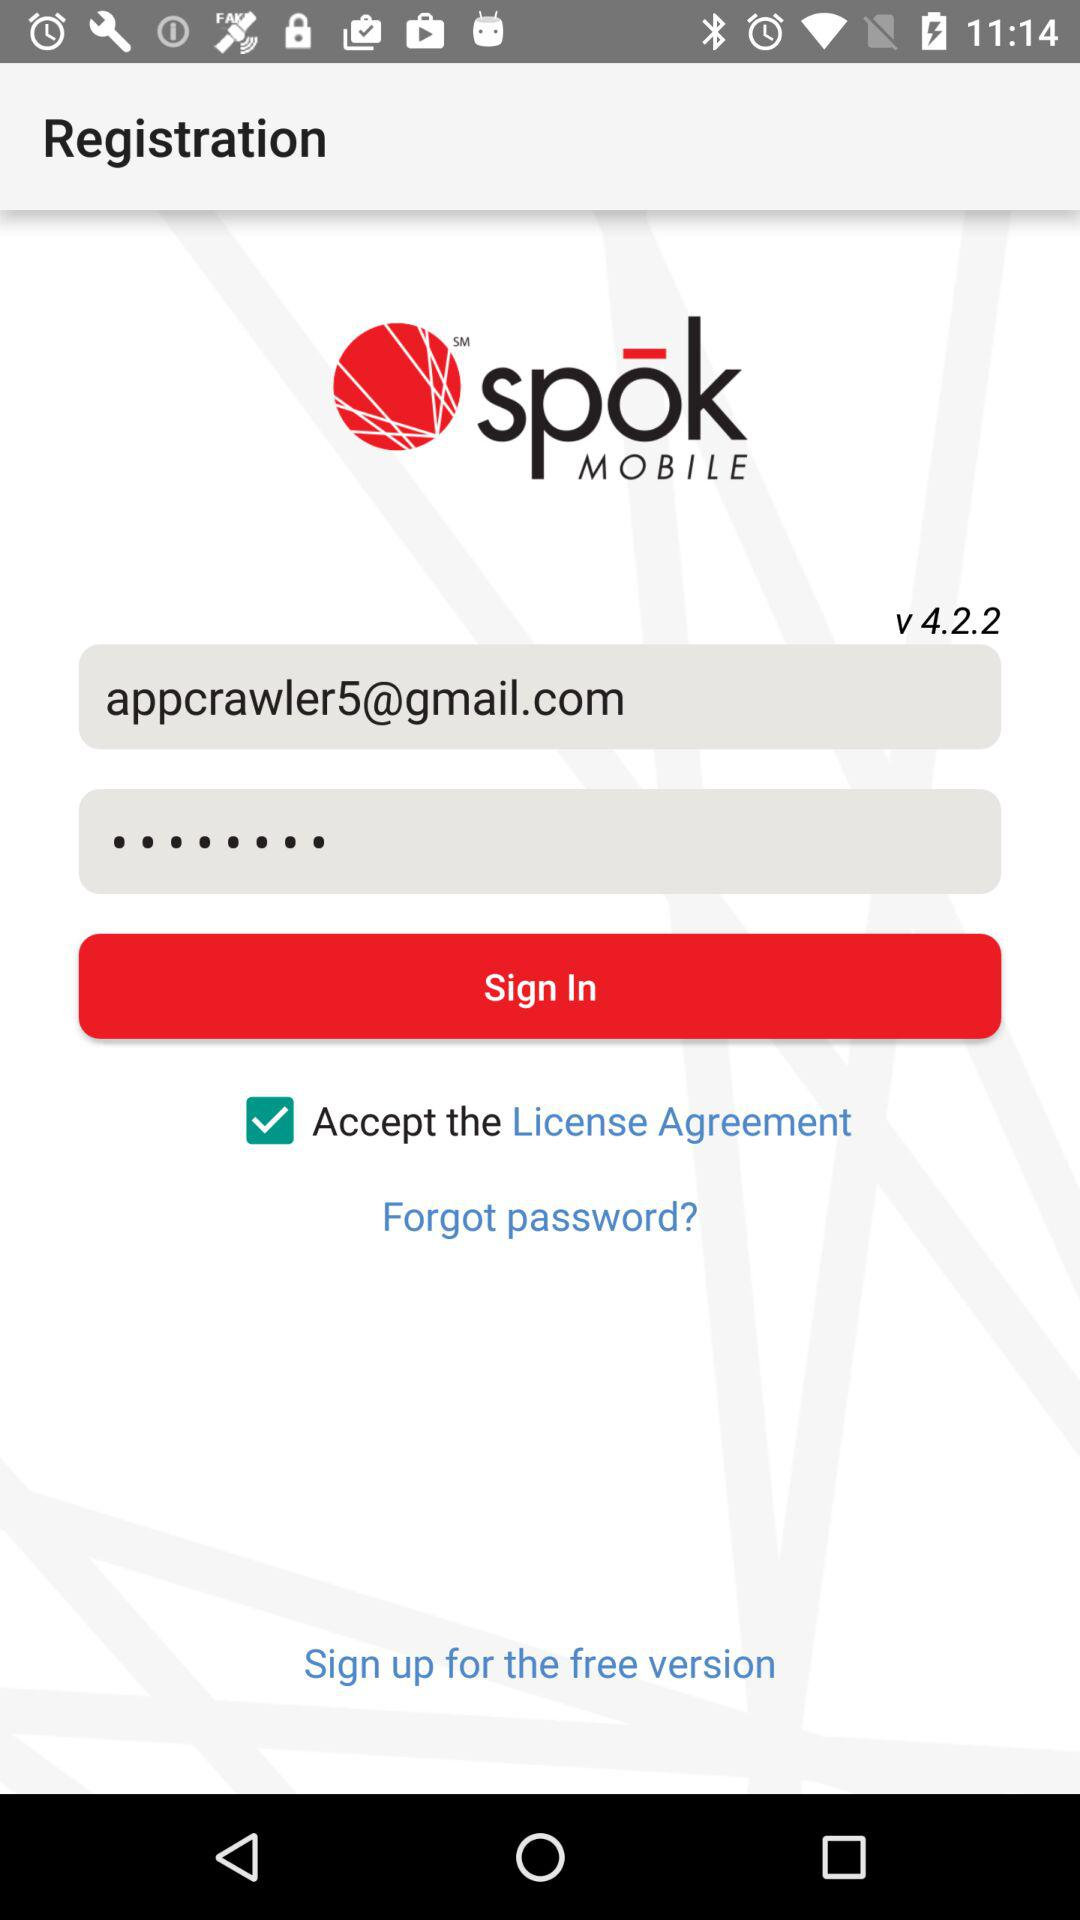How many text inputs have an email address in them?
Answer the question using a single word or phrase. 1 